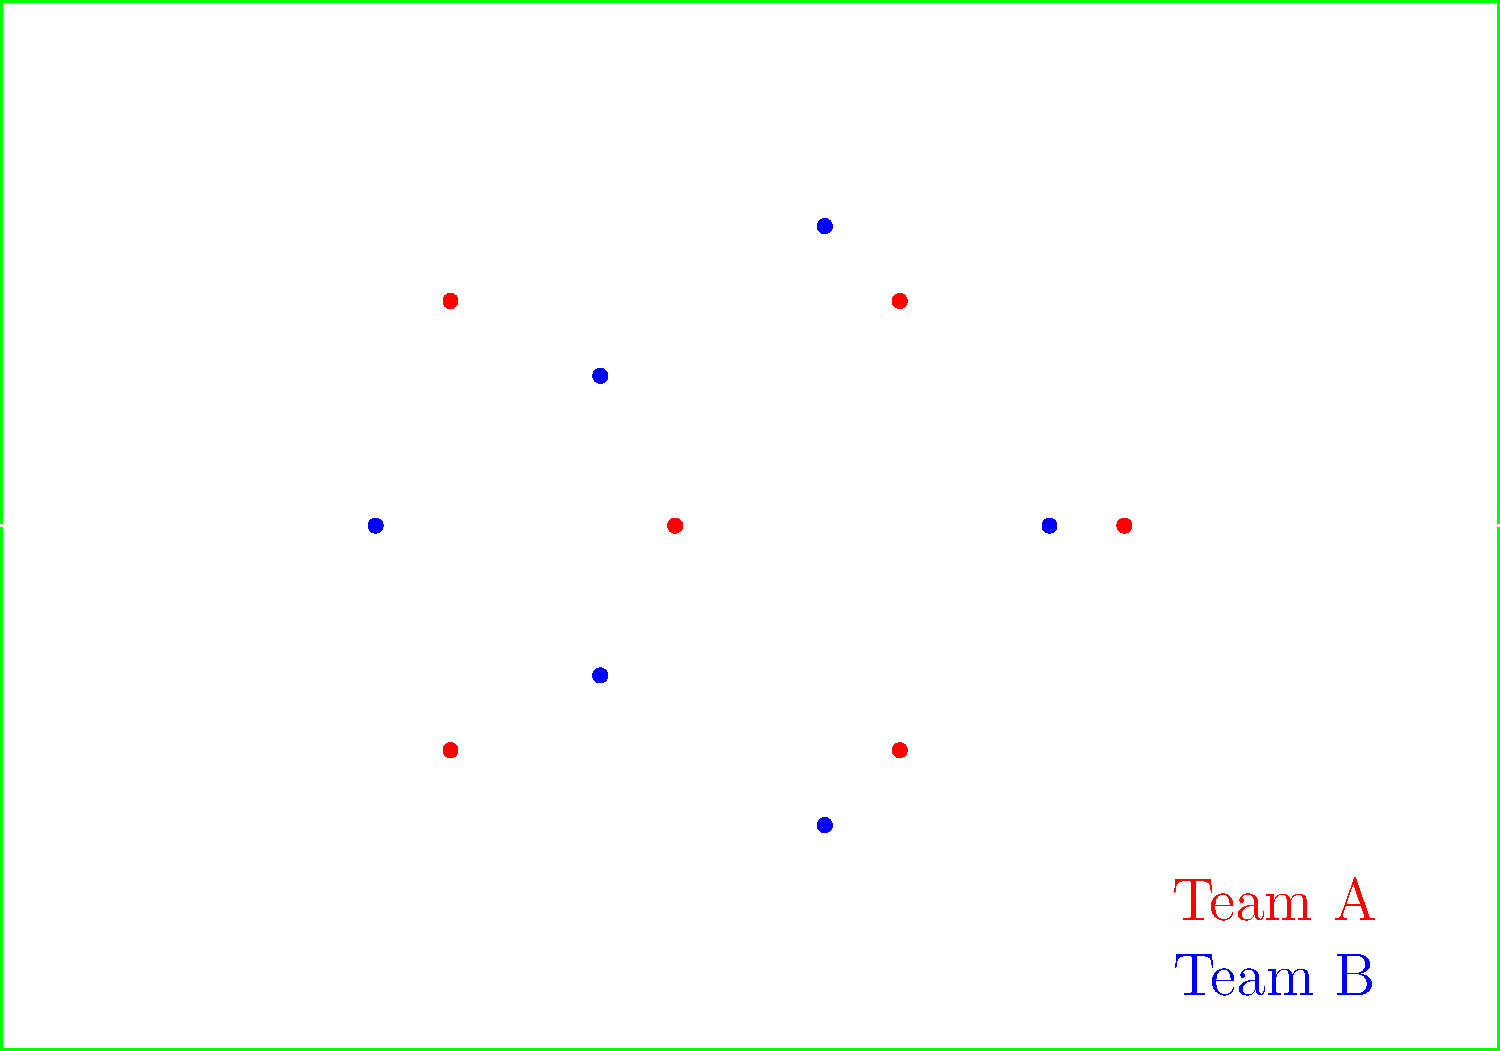Based on the aerial view of both teams' formations, which team appears to be using a more compact defensive shape, and how might this impact their ability to press the opposition? To analyze the team formations and determine which team has a more compact defensive shape, we need to consider the following steps:

1. Observe the overall positioning of players for each team:
   - Team A (red) is positioned in two vertical lines of three players each.
   - Team B (blue) is positioned in a more triangular or diamond-like shape.

2. Assess the spacing between players:
   - Team A's players are spread wider across the field.
   - Team B's players are closer together, creating smaller gaps between them.

3. Consider the area covered by each team:
   - Team A covers a larger area of the field.
   - Team B occupies a smaller, more centralized area.

4. Evaluate the compactness:
   - Team B has a more compact shape due to the smaller distances between players and the centralized positioning.

5. Analyze the impact on pressing:
   - A more compact shape (Team B) allows for easier coordination in pressing, as players can quickly support each other.
   - Shorter distances between players enable faster closing down of passing lanes.
   - The compact shape makes it easier to maintain pressure on the ball carrier and nearby opponents.

6. Consider the trade-offs:
   - While Team B's compact shape is better for pressing, it may leave more space on the wings for the opposition to exploit.
   - Team A's wider formation might be less effective for pressing but could provide better coverage of the entire field.

Based on this analysis, Team B appears to have the more compact defensive shape, which would likely enhance their ability to press the opposition effectively in central areas of the field.
Answer: Team B; more compact shape enables better coordination and faster pressing. 